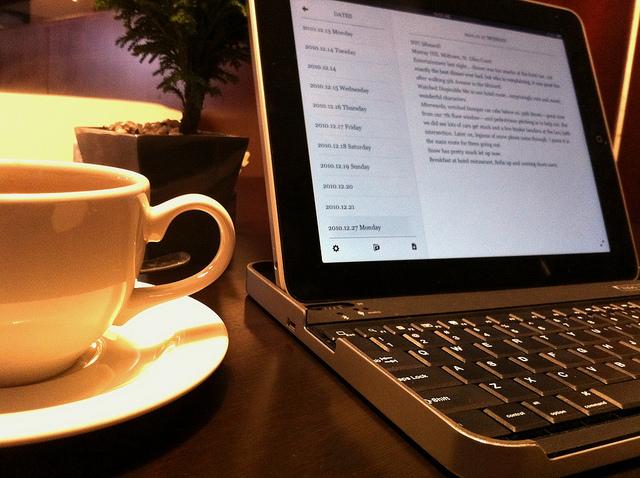Is there a bonsai in the background?
Short answer required. Yes. Is the laptop on?
Short answer required. Yes. Would these keys be legible in the dark?
Give a very brief answer. Yes. How many different colors are on the mug?
Give a very brief answer. 1. 